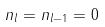Convert formula to latex. <formula><loc_0><loc_0><loc_500><loc_500>n _ { l } = n _ { l - 1 } = 0</formula> 